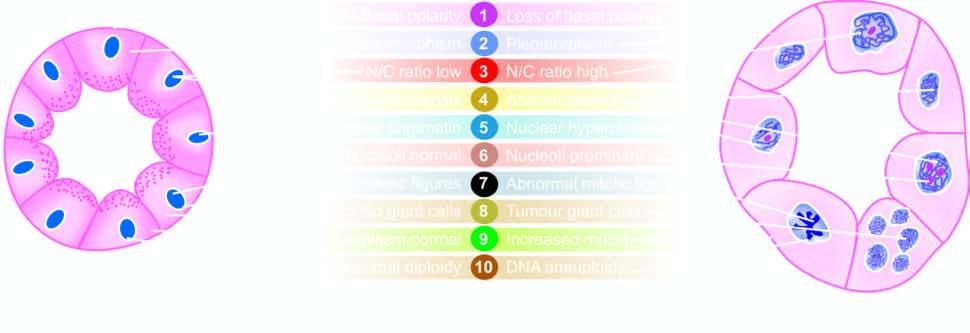what are characteristics of cancer in a gland contrasted with?
Answer the question using a single word or phrase. The appearance of an acinus 